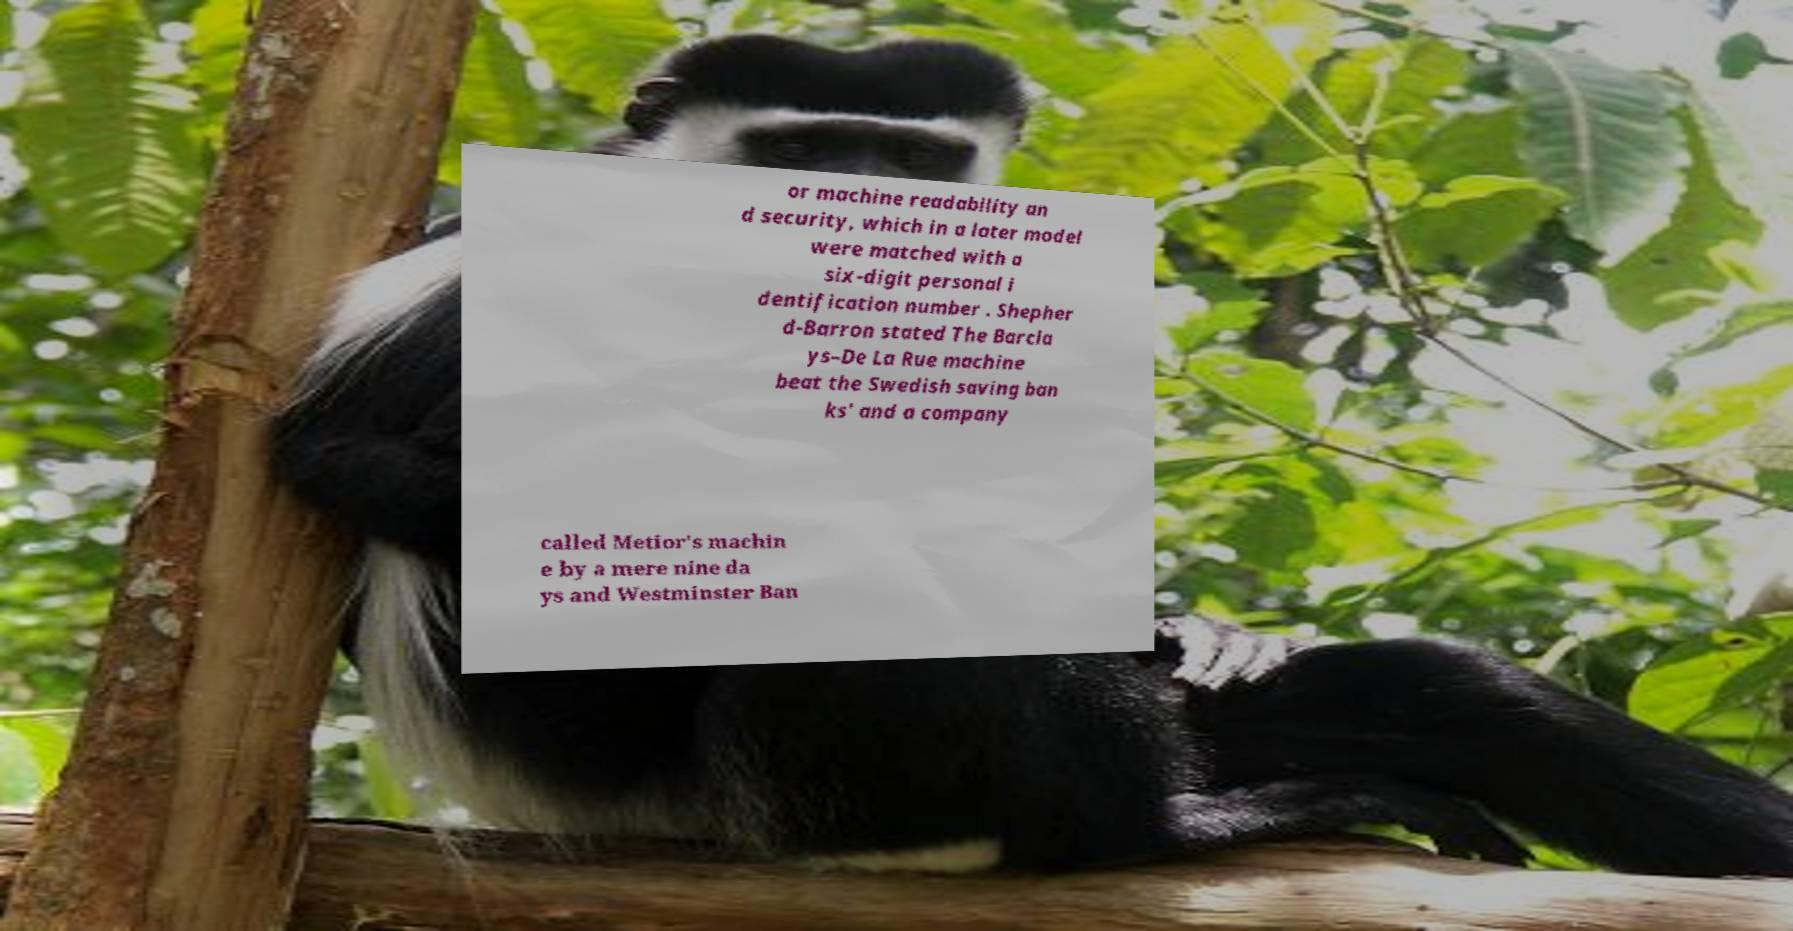Please identify and transcribe the text found in this image. or machine readability an d security, which in a later model were matched with a six-digit personal i dentification number . Shepher d-Barron stated The Barcla ys–De La Rue machine beat the Swedish saving ban ks' and a company called Metior's machin e by a mere nine da ys and Westminster Ban 